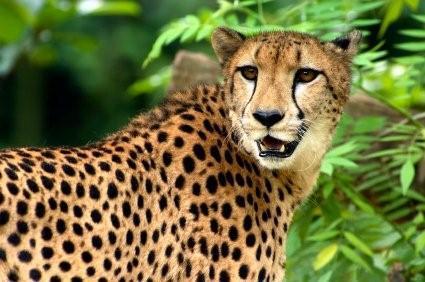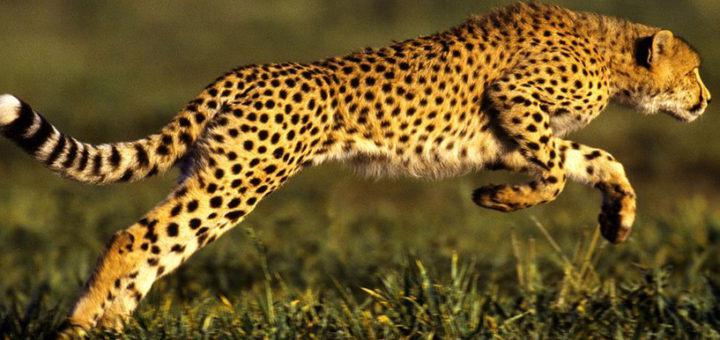The first image is the image on the left, the second image is the image on the right. Considering the images on both sides, is "The same number of cheetahs are present in the left and right images." valid? Answer yes or no. Yes. 